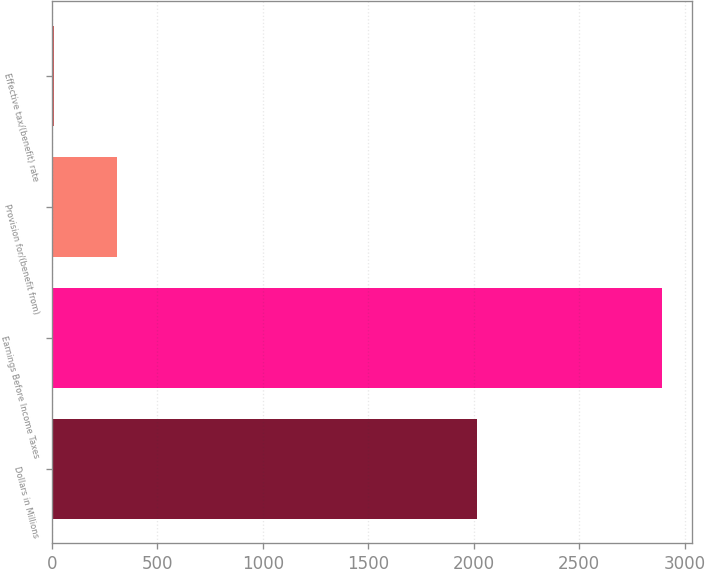Convert chart. <chart><loc_0><loc_0><loc_500><loc_500><bar_chart><fcel>Dollars in Millions<fcel>Earnings Before Income Taxes<fcel>Provision for/(benefit from)<fcel>Effective tax/(benefit) rate<nl><fcel>2013<fcel>2891<fcel>311<fcel>10.8<nl></chart> 